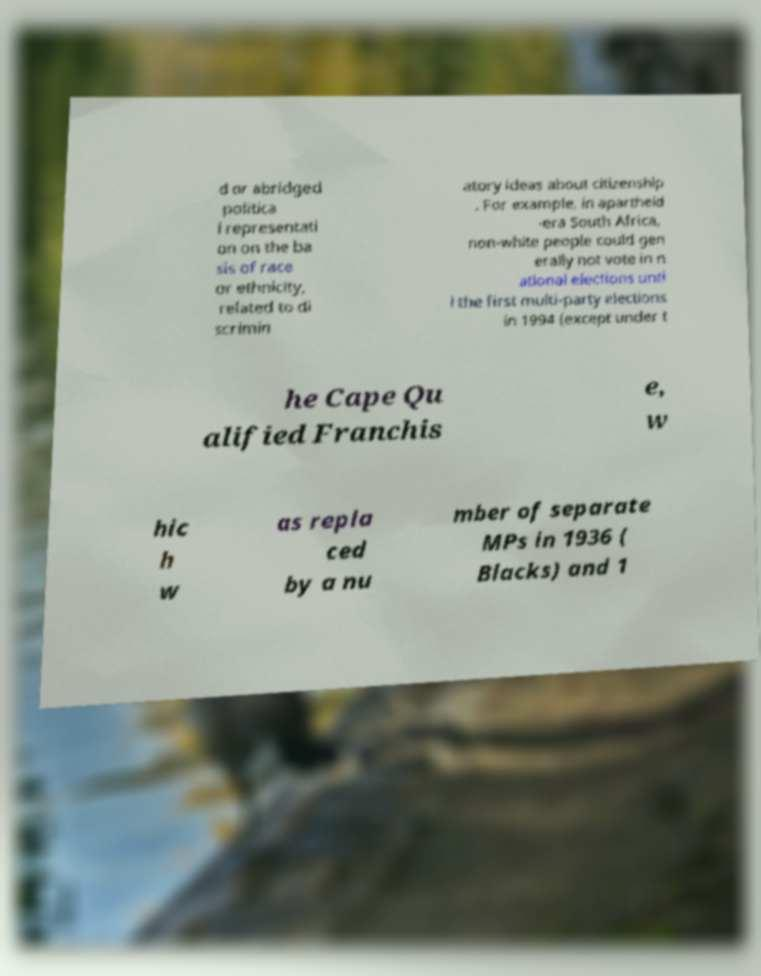Please read and relay the text visible in this image. What does it say? d or abridged politica l representati on on the ba sis of race or ethnicity, related to di scrimin atory ideas about citizenship . For example, in apartheid -era South Africa, non-white people could gen erally not vote in n ational elections unti l the first multi-party elections in 1994 (except under t he Cape Qu alified Franchis e, w hic h w as repla ced by a nu mber of separate MPs in 1936 ( Blacks) and 1 